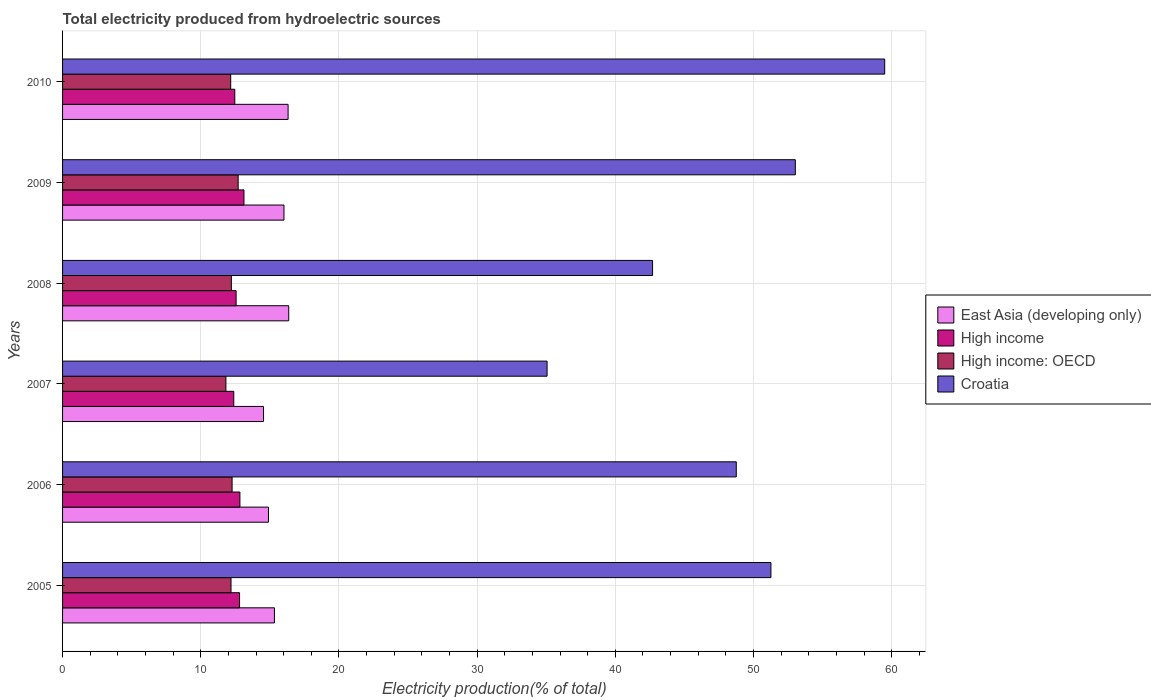How many groups of bars are there?
Offer a terse response. 6. Are the number of bars per tick equal to the number of legend labels?
Provide a succinct answer. Yes. Are the number of bars on each tick of the Y-axis equal?
Keep it short and to the point. Yes. What is the label of the 2nd group of bars from the top?
Make the answer very short. 2009. In how many cases, is the number of bars for a given year not equal to the number of legend labels?
Provide a short and direct response. 0. What is the total electricity produced in Croatia in 2010?
Offer a very short reply. 59.5. Across all years, what is the maximum total electricity produced in High income?
Your answer should be compact. 13.13. Across all years, what is the minimum total electricity produced in Croatia?
Give a very brief answer. 35.06. In which year was the total electricity produced in High income: OECD maximum?
Offer a very short reply. 2009. What is the total total electricity produced in High income in the graph?
Your answer should be very brief. 76.19. What is the difference between the total electricity produced in East Asia (developing only) in 2005 and that in 2010?
Your answer should be compact. -0.99. What is the difference between the total electricity produced in High income in 2006 and the total electricity produced in Croatia in 2010?
Give a very brief answer. -46.66. What is the average total electricity produced in High income: OECD per year?
Give a very brief answer. 12.23. In the year 2006, what is the difference between the total electricity produced in Croatia and total electricity produced in East Asia (developing only)?
Provide a short and direct response. 33.85. What is the ratio of the total electricity produced in East Asia (developing only) in 2005 to that in 2010?
Your answer should be compact. 0.94. Is the total electricity produced in High income in 2007 less than that in 2010?
Your answer should be compact. Yes. Is the difference between the total electricity produced in Croatia in 2009 and 2010 greater than the difference between the total electricity produced in East Asia (developing only) in 2009 and 2010?
Your response must be concise. No. What is the difference between the highest and the second highest total electricity produced in East Asia (developing only)?
Offer a terse response. 0.05. What is the difference between the highest and the lowest total electricity produced in High income: OECD?
Offer a terse response. 0.89. In how many years, is the total electricity produced in High income: OECD greater than the average total electricity produced in High income: OECD taken over all years?
Your answer should be compact. 2. Is the sum of the total electricity produced in Croatia in 2008 and 2010 greater than the maximum total electricity produced in East Asia (developing only) across all years?
Ensure brevity in your answer.  Yes. Is it the case that in every year, the sum of the total electricity produced in Croatia and total electricity produced in High income: OECD is greater than the sum of total electricity produced in East Asia (developing only) and total electricity produced in High income?
Keep it short and to the point. Yes. What does the 4th bar from the top in 2007 represents?
Provide a succinct answer. East Asia (developing only). What does the 3rd bar from the bottom in 2008 represents?
Offer a terse response. High income: OECD. Is it the case that in every year, the sum of the total electricity produced in High income and total electricity produced in East Asia (developing only) is greater than the total electricity produced in High income: OECD?
Your answer should be very brief. Yes. What is the difference between two consecutive major ticks on the X-axis?
Provide a succinct answer. 10. Are the values on the major ticks of X-axis written in scientific E-notation?
Your response must be concise. No. Does the graph contain any zero values?
Your answer should be compact. No. Where does the legend appear in the graph?
Your answer should be very brief. Center right. How many legend labels are there?
Your response must be concise. 4. How are the legend labels stacked?
Give a very brief answer. Vertical. What is the title of the graph?
Provide a succinct answer. Total electricity produced from hydroelectric sources. What is the label or title of the X-axis?
Make the answer very short. Electricity production(% of total). What is the Electricity production(% of total) of East Asia (developing only) in 2005?
Give a very brief answer. 15.33. What is the Electricity production(% of total) of High income in 2005?
Offer a very short reply. 12.81. What is the Electricity production(% of total) of High income: OECD in 2005?
Provide a short and direct response. 12.19. What is the Electricity production(% of total) of Croatia in 2005?
Ensure brevity in your answer.  51.26. What is the Electricity production(% of total) in East Asia (developing only) in 2006?
Provide a succinct answer. 14.9. What is the Electricity production(% of total) of High income in 2006?
Your answer should be compact. 12.83. What is the Electricity production(% of total) in High income: OECD in 2006?
Your answer should be compact. 12.27. What is the Electricity production(% of total) in Croatia in 2006?
Provide a succinct answer. 48.76. What is the Electricity production(% of total) of East Asia (developing only) in 2007?
Offer a very short reply. 14.54. What is the Electricity production(% of total) of High income in 2007?
Offer a very short reply. 12.39. What is the Electricity production(% of total) in High income: OECD in 2007?
Your answer should be compact. 11.82. What is the Electricity production(% of total) of Croatia in 2007?
Offer a very short reply. 35.06. What is the Electricity production(% of total) in East Asia (developing only) in 2008?
Your response must be concise. 16.37. What is the Electricity production(% of total) in High income in 2008?
Ensure brevity in your answer.  12.56. What is the Electricity production(% of total) of High income: OECD in 2008?
Your answer should be compact. 12.21. What is the Electricity production(% of total) of Croatia in 2008?
Your answer should be compact. 42.7. What is the Electricity production(% of total) of East Asia (developing only) in 2009?
Ensure brevity in your answer.  16.02. What is the Electricity production(% of total) in High income in 2009?
Ensure brevity in your answer.  13.13. What is the Electricity production(% of total) in High income: OECD in 2009?
Offer a very short reply. 12.71. What is the Electricity production(% of total) of Croatia in 2009?
Ensure brevity in your answer.  53.03. What is the Electricity production(% of total) in East Asia (developing only) in 2010?
Make the answer very short. 16.32. What is the Electricity production(% of total) in High income in 2010?
Make the answer very short. 12.46. What is the Electricity production(% of total) in High income: OECD in 2010?
Ensure brevity in your answer.  12.17. What is the Electricity production(% of total) in Croatia in 2010?
Provide a succinct answer. 59.5. Across all years, what is the maximum Electricity production(% of total) in East Asia (developing only)?
Your answer should be compact. 16.37. Across all years, what is the maximum Electricity production(% of total) in High income?
Give a very brief answer. 13.13. Across all years, what is the maximum Electricity production(% of total) of High income: OECD?
Keep it short and to the point. 12.71. Across all years, what is the maximum Electricity production(% of total) of Croatia?
Provide a succinct answer. 59.5. Across all years, what is the minimum Electricity production(% of total) in East Asia (developing only)?
Offer a very short reply. 14.54. Across all years, what is the minimum Electricity production(% of total) in High income?
Give a very brief answer. 12.39. Across all years, what is the minimum Electricity production(% of total) of High income: OECD?
Ensure brevity in your answer.  11.82. Across all years, what is the minimum Electricity production(% of total) of Croatia?
Offer a terse response. 35.06. What is the total Electricity production(% of total) of East Asia (developing only) in the graph?
Offer a very short reply. 93.49. What is the total Electricity production(% of total) of High income in the graph?
Your answer should be very brief. 76.19. What is the total Electricity production(% of total) in High income: OECD in the graph?
Your answer should be compact. 73.37. What is the total Electricity production(% of total) in Croatia in the graph?
Your response must be concise. 290.31. What is the difference between the Electricity production(% of total) of East Asia (developing only) in 2005 and that in 2006?
Provide a short and direct response. 0.43. What is the difference between the Electricity production(% of total) of High income in 2005 and that in 2006?
Offer a very short reply. -0.02. What is the difference between the Electricity production(% of total) in High income: OECD in 2005 and that in 2006?
Your response must be concise. -0.08. What is the difference between the Electricity production(% of total) in Croatia in 2005 and that in 2006?
Give a very brief answer. 2.51. What is the difference between the Electricity production(% of total) of East Asia (developing only) in 2005 and that in 2007?
Your answer should be compact. 0.79. What is the difference between the Electricity production(% of total) of High income in 2005 and that in 2007?
Make the answer very short. 0.42. What is the difference between the Electricity production(% of total) of High income: OECD in 2005 and that in 2007?
Offer a very short reply. 0.37. What is the difference between the Electricity production(% of total) in Croatia in 2005 and that in 2007?
Offer a very short reply. 16.2. What is the difference between the Electricity production(% of total) in East Asia (developing only) in 2005 and that in 2008?
Offer a terse response. -1.03. What is the difference between the Electricity production(% of total) of High income in 2005 and that in 2008?
Your response must be concise. 0.25. What is the difference between the Electricity production(% of total) in High income: OECD in 2005 and that in 2008?
Keep it short and to the point. -0.02. What is the difference between the Electricity production(% of total) in Croatia in 2005 and that in 2008?
Offer a terse response. 8.56. What is the difference between the Electricity production(% of total) in East Asia (developing only) in 2005 and that in 2009?
Keep it short and to the point. -0.69. What is the difference between the Electricity production(% of total) of High income in 2005 and that in 2009?
Your response must be concise. -0.32. What is the difference between the Electricity production(% of total) of High income: OECD in 2005 and that in 2009?
Offer a terse response. -0.52. What is the difference between the Electricity production(% of total) of Croatia in 2005 and that in 2009?
Provide a succinct answer. -1.77. What is the difference between the Electricity production(% of total) in East Asia (developing only) in 2005 and that in 2010?
Your answer should be very brief. -0.99. What is the difference between the Electricity production(% of total) of High income in 2005 and that in 2010?
Your response must be concise. 0.35. What is the difference between the Electricity production(% of total) of High income: OECD in 2005 and that in 2010?
Give a very brief answer. 0.02. What is the difference between the Electricity production(% of total) in Croatia in 2005 and that in 2010?
Your answer should be compact. -8.23. What is the difference between the Electricity production(% of total) in East Asia (developing only) in 2006 and that in 2007?
Provide a succinct answer. 0.36. What is the difference between the Electricity production(% of total) in High income in 2006 and that in 2007?
Give a very brief answer. 0.44. What is the difference between the Electricity production(% of total) in High income: OECD in 2006 and that in 2007?
Offer a terse response. 0.45. What is the difference between the Electricity production(% of total) of Croatia in 2006 and that in 2007?
Give a very brief answer. 13.69. What is the difference between the Electricity production(% of total) of East Asia (developing only) in 2006 and that in 2008?
Offer a very short reply. -1.47. What is the difference between the Electricity production(% of total) in High income in 2006 and that in 2008?
Provide a short and direct response. 0.27. What is the difference between the Electricity production(% of total) of High income: OECD in 2006 and that in 2008?
Offer a very short reply. 0.05. What is the difference between the Electricity production(% of total) in Croatia in 2006 and that in 2008?
Provide a succinct answer. 6.06. What is the difference between the Electricity production(% of total) of East Asia (developing only) in 2006 and that in 2009?
Give a very brief answer. -1.12. What is the difference between the Electricity production(% of total) in High income in 2006 and that in 2009?
Make the answer very short. -0.29. What is the difference between the Electricity production(% of total) of High income: OECD in 2006 and that in 2009?
Keep it short and to the point. -0.44. What is the difference between the Electricity production(% of total) of Croatia in 2006 and that in 2009?
Ensure brevity in your answer.  -4.27. What is the difference between the Electricity production(% of total) in East Asia (developing only) in 2006 and that in 2010?
Make the answer very short. -1.42. What is the difference between the Electricity production(% of total) in High income in 2006 and that in 2010?
Offer a terse response. 0.37. What is the difference between the Electricity production(% of total) in High income: OECD in 2006 and that in 2010?
Make the answer very short. 0.1. What is the difference between the Electricity production(% of total) of Croatia in 2006 and that in 2010?
Your answer should be compact. -10.74. What is the difference between the Electricity production(% of total) of East Asia (developing only) in 2007 and that in 2008?
Give a very brief answer. -1.82. What is the difference between the Electricity production(% of total) in High income in 2007 and that in 2008?
Give a very brief answer. -0.17. What is the difference between the Electricity production(% of total) of High income: OECD in 2007 and that in 2008?
Keep it short and to the point. -0.39. What is the difference between the Electricity production(% of total) in Croatia in 2007 and that in 2008?
Your response must be concise. -7.63. What is the difference between the Electricity production(% of total) in East Asia (developing only) in 2007 and that in 2009?
Keep it short and to the point. -1.48. What is the difference between the Electricity production(% of total) in High income in 2007 and that in 2009?
Ensure brevity in your answer.  -0.74. What is the difference between the Electricity production(% of total) of High income: OECD in 2007 and that in 2009?
Offer a terse response. -0.89. What is the difference between the Electricity production(% of total) of Croatia in 2007 and that in 2009?
Offer a very short reply. -17.97. What is the difference between the Electricity production(% of total) in East Asia (developing only) in 2007 and that in 2010?
Make the answer very short. -1.78. What is the difference between the Electricity production(% of total) in High income in 2007 and that in 2010?
Provide a short and direct response. -0.07. What is the difference between the Electricity production(% of total) in High income: OECD in 2007 and that in 2010?
Ensure brevity in your answer.  -0.35. What is the difference between the Electricity production(% of total) of Croatia in 2007 and that in 2010?
Make the answer very short. -24.43. What is the difference between the Electricity production(% of total) of East Asia (developing only) in 2008 and that in 2009?
Offer a very short reply. 0.34. What is the difference between the Electricity production(% of total) of High income in 2008 and that in 2009?
Offer a terse response. -0.57. What is the difference between the Electricity production(% of total) of High income: OECD in 2008 and that in 2009?
Make the answer very short. -0.49. What is the difference between the Electricity production(% of total) in Croatia in 2008 and that in 2009?
Your response must be concise. -10.33. What is the difference between the Electricity production(% of total) of East Asia (developing only) in 2008 and that in 2010?
Your answer should be very brief. 0.05. What is the difference between the Electricity production(% of total) of High income in 2008 and that in 2010?
Your answer should be very brief. 0.1. What is the difference between the Electricity production(% of total) of High income: OECD in 2008 and that in 2010?
Ensure brevity in your answer.  0.05. What is the difference between the Electricity production(% of total) of Croatia in 2008 and that in 2010?
Your response must be concise. -16.8. What is the difference between the Electricity production(% of total) of East Asia (developing only) in 2009 and that in 2010?
Offer a very short reply. -0.3. What is the difference between the Electricity production(% of total) in High income in 2009 and that in 2010?
Ensure brevity in your answer.  0.66. What is the difference between the Electricity production(% of total) in High income: OECD in 2009 and that in 2010?
Provide a short and direct response. 0.54. What is the difference between the Electricity production(% of total) of Croatia in 2009 and that in 2010?
Your answer should be compact. -6.47. What is the difference between the Electricity production(% of total) in East Asia (developing only) in 2005 and the Electricity production(% of total) in High income in 2006?
Give a very brief answer. 2.5. What is the difference between the Electricity production(% of total) of East Asia (developing only) in 2005 and the Electricity production(% of total) of High income: OECD in 2006?
Provide a succinct answer. 3.06. What is the difference between the Electricity production(% of total) of East Asia (developing only) in 2005 and the Electricity production(% of total) of Croatia in 2006?
Your response must be concise. -33.42. What is the difference between the Electricity production(% of total) in High income in 2005 and the Electricity production(% of total) in High income: OECD in 2006?
Offer a very short reply. 0.54. What is the difference between the Electricity production(% of total) of High income in 2005 and the Electricity production(% of total) of Croatia in 2006?
Provide a succinct answer. -35.95. What is the difference between the Electricity production(% of total) of High income: OECD in 2005 and the Electricity production(% of total) of Croatia in 2006?
Make the answer very short. -36.57. What is the difference between the Electricity production(% of total) of East Asia (developing only) in 2005 and the Electricity production(% of total) of High income in 2007?
Offer a terse response. 2.94. What is the difference between the Electricity production(% of total) in East Asia (developing only) in 2005 and the Electricity production(% of total) in High income: OECD in 2007?
Your answer should be compact. 3.51. What is the difference between the Electricity production(% of total) of East Asia (developing only) in 2005 and the Electricity production(% of total) of Croatia in 2007?
Provide a short and direct response. -19.73. What is the difference between the Electricity production(% of total) in High income in 2005 and the Electricity production(% of total) in High income: OECD in 2007?
Your answer should be compact. 0.99. What is the difference between the Electricity production(% of total) of High income in 2005 and the Electricity production(% of total) of Croatia in 2007?
Your answer should be very brief. -22.25. What is the difference between the Electricity production(% of total) in High income: OECD in 2005 and the Electricity production(% of total) in Croatia in 2007?
Ensure brevity in your answer.  -22.87. What is the difference between the Electricity production(% of total) in East Asia (developing only) in 2005 and the Electricity production(% of total) in High income in 2008?
Give a very brief answer. 2.77. What is the difference between the Electricity production(% of total) of East Asia (developing only) in 2005 and the Electricity production(% of total) of High income: OECD in 2008?
Give a very brief answer. 3.12. What is the difference between the Electricity production(% of total) of East Asia (developing only) in 2005 and the Electricity production(% of total) of Croatia in 2008?
Your answer should be compact. -27.37. What is the difference between the Electricity production(% of total) in High income in 2005 and the Electricity production(% of total) in High income: OECD in 2008?
Your response must be concise. 0.59. What is the difference between the Electricity production(% of total) in High income in 2005 and the Electricity production(% of total) in Croatia in 2008?
Your answer should be very brief. -29.89. What is the difference between the Electricity production(% of total) of High income: OECD in 2005 and the Electricity production(% of total) of Croatia in 2008?
Make the answer very short. -30.51. What is the difference between the Electricity production(% of total) of East Asia (developing only) in 2005 and the Electricity production(% of total) of High income in 2009?
Your answer should be compact. 2.2. What is the difference between the Electricity production(% of total) in East Asia (developing only) in 2005 and the Electricity production(% of total) in High income: OECD in 2009?
Make the answer very short. 2.63. What is the difference between the Electricity production(% of total) of East Asia (developing only) in 2005 and the Electricity production(% of total) of Croatia in 2009?
Keep it short and to the point. -37.7. What is the difference between the Electricity production(% of total) in High income in 2005 and the Electricity production(% of total) in High income: OECD in 2009?
Your answer should be compact. 0.1. What is the difference between the Electricity production(% of total) in High income in 2005 and the Electricity production(% of total) in Croatia in 2009?
Offer a very short reply. -40.22. What is the difference between the Electricity production(% of total) of High income: OECD in 2005 and the Electricity production(% of total) of Croatia in 2009?
Give a very brief answer. -40.84. What is the difference between the Electricity production(% of total) of East Asia (developing only) in 2005 and the Electricity production(% of total) of High income in 2010?
Provide a succinct answer. 2.87. What is the difference between the Electricity production(% of total) in East Asia (developing only) in 2005 and the Electricity production(% of total) in High income: OECD in 2010?
Your answer should be very brief. 3.16. What is the difference between the Electricity production(% of total) in East Asia (developing only) in 2005 and the Electricity production(% of total) in Croatia in 2010?
Offer a very short reply. -44.16. What is the difference between the Electricity production(% of total) of High income in 2005 and the Electricity production(% of total) of High income: OECD in 2010?
Provide a succinct answer. 0.64. What is the difference between the Electricity production(% of total) in High income in 2005 and the Electricity production(% of total) in Croatia in 2010?
Your answer should be compact. -46.69. What is the difference between the Electricity production(% of total) of High income: OECD in 2005 and the Electricity production(% of total) of Croatia in 2010?
Offer a terse response. -47.31. What is the difference between the Electricity production(% of total) of East Asia (developing only) in 2006 and the Electricity production(% of total) of High income in 2007?
Keep it short and to the point. 2.51. What is the difference between the Electricity production(% of total) of East Asia (developing only) in 2006 and the Electricity production(% of total) of High income: OECD in 2007?
Keep it short and to the point. 3.08. What is the difference between the Electricity production(% of total) in East Asia (developing only) in 2006 and the Electricity production(% of total) in Croatia in 2007?
Your answer should be very brief. -20.16. What is the difference between the Electricity production(% of total) of High income in 2006 and the Electricity production(% of total) of High income: OECD in 2007?
Offer a very short reply. 1.01. What is the difference between the Electricity production(% of total) of High income in 2006 and the Electricity production(% of total) of Croatia in 2007?
Your answer should be very brief. -22.23. What is the difference between the Electricity production(% of total) of High income: OECD in 2006 and the Electricity production(% of total) of Croatia in 2007?
Offer a very short reply. -22.8. What is the difference between the Electricity production(% of total) in East Asia (developing only) in 2006 and the Electricity production(% of total) in High income in 2008?
Ensure brevity in your answer.  2.34. What is the difference between the Electricity production(% of total) in East Asia (developing only) in 2006 and the Electricity production(% of total) in High income: OECD in 2008?
Offer a very short reply. 2.69. What is the difference between the Electricity production(% of total) of East Asia (developing only) in 2006 and the Electricity production(% of total) of Croatia in 2008?
Provide a short and direct response. -27.8. What is the difference between the Electricity production(% of total) in High income in 2006 and the Electricity production(% of total) in High income: OECD in 2008?
Make the answer very short. 0.62. What is the difference between the Electricity production(% of total) in High income in 2006 and the Electricity production(% of total) in Croatia in 2008?
Offer a very short reply. -29.86. What is the difference between the Electricity production(% of total) in High income: OECD in 2006 and the Electricity production(% of total) in Croatia in 2008?
Offer a terse response. -30.43. What is the difference between the Electricity production(% of total) of East Asia (developing only) in 2006 and the Electricity production(% of total) of High income in 2009?
Provide a short and direct response. 1.77. What is the difference between the Electricity production(% of total) of East Asia (developing only) in 2006 and the Electricity production(% of total) of High income: OECD in 2009?
Your response must be concise. 2.19. What is the difference between the Electricity production(% of total) in East Asia (developing only) in 2006 and the Electricity production(% of total) in Croatia in 2009?
Ensure brevity in your answer.  -38.13. What is the difference between the Electricity production(% of total) of High income in 2006 and the Electricity production(% of total) of High income: OECD in 2009?
Offer a terse response. 0.13. What is the difference between the Electricity production(% of total) of High income in 2006 and the Electricity production(% of total) of Croatia in 2009?
Give a very brief answer. -40.2. What is the difference between the Electricity production(% of total) in High income: OECD in 2006 and the Electricity production(% of total) in Croatia in 2009?
Offer a very short reply. -40.76. What is the difference between the Electricity production(% of total) of East Asia (developing only) in 2006 and the Electricity production(% of total) of High income in 2010?
Your answer should be very brief. 2.44. What is the difference between the Electricity production(% of total) of East Asia (developing only) in 2006 and the Electricity production(% of total) of High income: OECD in 2010?
Make the answer very short. 2.73. What is the difference between the Electricity production(% of total) in East Asia (developing only) in 2006 and the Electricity production(% of total) in Croatia in 2010?
Give a very brief answer. -44.59. What is the difference between the Electricity production(% of total) in High income in 2006 and the Electricity production(% of total) in High income: OECD in 2010?
Your answer should be compact. 0.67. What is the difference between the Electricity production(% of total) in High income in 2006 and the Electricity production(% of total) in Croatia in 2010?
Ensure brevity in your answer.  -46.66. What is the difference between the Electricity production(% of total) in High income: OECD in 2006 and the Electricity production(% of total) in Croatia in 2010?
Give a very brief answer. -47.23. What is the difference between the Electricity production(% of total) in East Asia (developing only) in 2007 and the Electricity production(% of total) in High income in 2008?
Your answer should be very brief. 1.98. What is the difference between the Electricity production(% of total) of East Asia (developing only) in 2007 and the Electricity production(% of total) of High income: OECD in 2008?
Offer a terse response. 2.33. What is the difference between the Electricity production(% of total) in East Asia (developing only) in 2007 and the Electricity production(% of total) in Croatia in 2008?
Give a very brief answer. -28.15. What is the difference between the Electricity production(% of total) of High income in 2007 and the Electricity production(% of total) of High income: OECD in 2008?
Your answer should be compact. 0.17. What is the difference between the Electricity production(% of total) in High income in 2007 and the Electricity production(% of total) in Croatia in 2008?
Offer a very short reply. -30.31. What is the difference between the Electricity production(% of total) in High income: OECD in 2007 and the Electricity production(% of total) in Croatia in 2008?
Provide a short and direct response. -30.88. What is the difference between the Electricity production(% of total) of East Asia (developing only) in 2007 and the Electricity production(% of total) of High income in 2009?
Provide a short and direct response. 1.42. What is the difference between the Electricity production(% of total) in East Asia (developing only) in 2007 and the Electricity production(% of total) in High income: OECD in 2009?
Provide a short and direct response. 1.84. What is the difference between the Electricity production(% of total) of East Asia (developing only) in 2007 and the Electricity production(% of total) of Croatia in 2009?
Your response must be concise. -38.49. What is the difference between the Electricity production(% of total) of High income in 2007 and the Electricity production(% of total) of High income: OECD in 2009?
Your answer should be compact. -0.32. What is the difference between the Electricity production(% of total) in High income in 2007 and the Electricity production(% of total) in Croatia in 2009?
Make the answer very short. -40.64. What is the difference between the Electricity production(% of total) of High income: OECD in 2007 and the Electricity production(% of total) of Croatia in 2009?
Give a very brief answer. -41.21. What is the difference between the Electricity production(% of total) of East Asia (developing only) in 2007 and the Electricity production(% of total) of High income in 2010?
Your response must be concise. 2.08. What is the difference between the Electricity production(% of total) of East Asia (developing only) in 2007 and the Electricity production(% of total) of High income: OECD in 2010?
Provide a short and direct response. 2.38. What is the difference between the Electricity production(% of total) of East Asia (developing only) in 2007 and the Electricity production(% of total) of Croatia in 2010?
Offer a terse response. -44.95. What is the difference between the Electricity production(% of total) in High income in 2007 and the Electricity production(% of total) in High income: OECD in 2010?
Offer a very short reply. 0.22. What is the difference between the Electricity production(% of total) of High income in 2007 and the Electricity production(% of total) of Croatia in 2010?
Your answer should be compact. -47.11. What is the difference between the Electricity production(% of total) of High income: OECD in 2007 and the Electricity production(% of total) of Croatia in 2010?
Offer a very short reply. -47.68. What is the difference between the Electricity production(% of total) of East Asia (developing only) in 2008 and the Electricity production(% of total) of High income in 2009?
Provide a succinct answer. 3.24. What is the difference between the Electricity production(% of total) in East Asia (developing only) in 2008 and the Electricity production(% of total) in High income: OECD in 2009?
Offer a terse response. 3.66. What is the difference between the Electricity production(% of total) of East Asia (developing only) in 2008 and the Electricity production(% of total) of Croatia in 2009?
Make the answer very short. -36.66. What is the difference between the Electricity production(% of total) of High income in 2008 and the Electricity production(% of total) of High income: OECD in 2009?
Give a very brief answer. -0.15. What is the difference between the Electricity production(% of total) in High income in 2008 and the Electricity production(% of total) in Croatia in 2009?
Your answer should be very brief. -40.47. What is the difference between the Electricity production(% of total) in High income: OECD in 2008 and the Electricity production(% of total) in Croatia in 2009?
Your response must be concise. -40.81. What is the difference between the Electricity production(% of total) in East Asia (developing only) in 2008 and the Electricity production(% of total) in High income in 2010?
Your answer should be very brief. 3.9. What is the difference between the Electricity production(% of total) in East Asia (developing only) in 2008 and the Electricity production(% of total) in High income: OECD in 2010?
Provide a succinct answer. 4.2. What is the difference between the Electricity production(% of total) in East Asia (developing only) in 2008 and the Electricity production(% of total) in Croatia in 2010?
Provide a succinct answer. -43.13. What is the difference between the Electricity production(% of total) in High income in 2008 and the Electricity production(% of total) in High income: OECD in 2010?
Offer a very short reply. 0.39. What is the difference between the Electricity production(% of total) of High income in 2008 and the Electricity production(% of total) of Croatia in 2010?
Provide a succinct answer. -46.94. What is the difference between the Electricity production(% of total) of High income: OECD in 2008 and the Electricity production(% of total) of Croatia in 2010?
Ensure brevity in your answer.  -47.28. What is the difference between the Electricity production(% of total) of East Asia (developing only) in 2009 and the Electricity production(% of total) of High income in 2010?
Provide a succinct answer. 3.56. What is the difference between the Electricity production(% of total) in East Asia (developing only) in 2009 and the Electricity production(% of total) in High income: OECD in 2010?
Offer a very short reply. 3.85. What is the difference between the Electricity production(% of total) in East Asia (developing only) in 2009 and the Electricity production(% of total) in Croatia in 2010?
Keep it short and to the point. -43.47. What is the difference between the Electricity production(% of total) in High income in 2009 and the Electricity production(% of total) in High income: OECD in 2010?
Offer a terse response. 0.96. What is the difference between the Electricity production(% of total) of High income in 2009 and the Electricity production(% of total) of Croatia in 2010?
Offer a terse response. -46.37. What is the difference between the Electricity production(% of total) in High income: OECD in 2009 and the Electricity production(% of total) in Croatia in 2010?
Your response must be concise. -46.79. What is the average Electricity production(% of total) of East Asia (developing only) per year?
Make the answer very short. 15.58. What is the average Electricity production(% of total) of High income per year?
Provide a short and direct response. 12.7. What is the average Electricity production(% of total) of High income: OECD per year?
Ensure brevity in your answer.  12.23. What is the average Electricity production(% of total) of Croatia per year?
Provide a short and direct response. 48.38. In the year 2005, what is the difference between the Electricity production(% of total) in East Asia (developing only) and Electricity production(% of total) in High income?
Make the answer very short. 2.52. In the year 2005, what is the difference between the Electricity production(% of total) of East Asia (developing only) and Electricity production(% of total) of High income: OECD?
Your response must be concise. 3.14. In the year 2005, what is the difference between the Electricity production(% of total) of East Asia (developing only) and Electricity production(% of total) of Croatia?
Your response must be concise. -35.93. In the year 2005, what is the difference between the Electricity production(% of total) in High income and Electricity production(% of total) in High income: OECD?
Make the answer very short. 0.62. In the year 2005, what is the difference between the Electricity production(% of total) of High income and Electricity production(% of total) of Croatia?
Your answer should be very brief. -38.45. In the year 2005, what is the difference between the Electricity production(% of total) of High income: OECD and Electricity production(% of total) of Croatia?
Keep it short and to the point. -39.07. In the year 2006, what is the difference between the Electricity production(% of total) of East Asia (developing only) and Electricity production(% of total) of High income?
Give a very brief answer. 2.07. In the year 2006, what is the difference between the Electricity production(% of total) of East Asia (developing only) and Electricity production(% of total) of High income: OECD?
Provide a short and direct response. 2.63. In the year 2006, what is the difference between the Electricity production(% of total) of East Asia (developing only) and Electricity production(% of total) of Croatia?
Make the answer very short. -33.85. In the year 2006, what is the difference between the Electricity production(% of total) of High income and Electricity production(% of total) of High income: OECD?
Ensure brevity in your answer.  0.57. In the year 2006, what is the difference between the Electricity production(% of total) in High income and Electricity production(% of total) in Croatia?
Your answer should be very brief. -35.92. In the year 2006, what is the difference between the Electricity production(% of total) of High income: OECD and Electricity production(% of total) of Croatia?
Your answer should be very brief. -36.49. In the year 2007, what is the difference between the Electricity production(% of total) of East Asia (developing only) and Electricity production(% of total) of High income?
Your answer should be very brief. 2.15. In the year 2007, what is the difference between the Electricity production(% of total) of East Asia (developing only) and Electricity production(% of total) of High income: OECD?
Provide a succinct answer. 2.72. In the year 2007, what is the difference between the Electricity production(% of total) of East Asia (developing only) and Electricity production(% of total) of Croatia?
Your response must be concise. -20.52. In the year 2007, what is the difference between the Electricity production(% of total) in High income and Electricity production(% of total) in High income: OECD?
Provide a short and direct response. 0.57. In the year 2007, what is the difference between the Electricity production(% of total) of High income and Electricity production(% of total) of Croatia?
Provide a short and direct response. -22.67. In the year 2007, what is the difference between the Electricity production(% of total) of High income: OECD and Electricity production(% of total) of Croatia?
Give a very brief answer. -23.24. In the year 2008, what is the difference between the Electricity production(% of total) in East Asia (developing only) and Electricity production(% of total) in High income?
Offer a very short reply. 3.81. In the year 2008, what is the difference between the Electricity production(% of total) of East Asia (developing only) and Electricity production(% of total) of High income: OECD?
Keep it short and to the point. 4.15. In the year 2008, what is the difference between the Electricity production(% of total) in East Asia (developing only) and Electricity production(% of total) in Croatia?
Your answer should be compact. -26.33. In the year 2008, what is the difference between the Electricity production(% of total) in High income and Electricity production(% of total) in High income: OECD?
Provide a succinct answer. 0.34. In the year 2008, what is the difference between the Electricity production(% of total) of High income and Electricity production(% of total) of Croatia?
Your answer should be very brief. -30.14. In the year 2008, what is the difference between the Electricity production(% of total) in High income: OECD and Electricity production(% of total) in Croatia?
Make the answer very short. -30.48. In the year 2009, what is the difference between the Electricity production(% of total) of East Asia (developing only) and Electricity production(% of total) of High income?
Give a very brief answer. 2.89. In the year 2009, what is the difference between the Electricity production(% of total) of East Asia (developing only) and Electricity production(% of total) of High income: OECD?
Your answer should be compact. 3.32. In the year 2009, what is the difference between the Electricity production(% of total) in East Asia (developing only) and Electricity production(% of total) in Croatia?
Your answer should be very brief. -37.01. In the year 2009, what is the difference between the Electricity production(% of total) of High income and Electricity production(% of total) of High income: OECD?
Make the answer very short. 0.42. In the year 2009, what is the difference between the Electricity production(% of total) of High income and Electricity production(% of total) of Croatia?
Ensure brevity in your answer.  -39.9. In the year 2009, what is the difference between the Electricity production(% of total) in High income: OECD and Electricity production(% of total) in Croatia?
Ensure brevity in your answer.  -40.32. In the year 2010, what is the difference between the Electricity production(% of total) of East Asia (developing only) and Electricity production(% of total) of High income?
Ensure brevity in your answer.  3.86. In the year 2010, what is the difference between the Electricity production(% of total) in East Asia (developing only) and Electricity production(% of total) in High income: OECD?
Offer a very short reply. 4.15. In the year 2010, what is the difference between the Electricity production(% of total) in East Asia (developing only) and Electricity production(% of total) in Croatia?
Provide a short and direct response. -43.18. In the year 2010, what is the difference between the Electricity production(% of total) of High income and Electricity production(% of total) of High income: OECD?
Give a very brief answer. 0.3. In the year 2010, what is the difference between the Electricity production(% of total) in High income and Electricity production(% of total) in Croatia?
Provide a short and direct response. -47.03. In the year 2010, what is the difference between the Electricity production(% of total) in High income: OECD and Electricity production(% of total) in Croatia?
Provide a succinct answer. -47.33. What is the ratio of the Electricity production(% of total) in East Asia (developing only) in 2005 to that in 2006?
Make the answer very short. 1.03. What is the ratio of the Electricity production(% of total) of Croatia in 2005 to that in 2006?
Provide a succinct answer. 1.05. What is the ratio of the Electricity production(% of total) in East Asia (developing only) in 2005 to that in 2007?
Offer a very short reply. 1.05. What is the ratio of the Electricity production(% of total) in High income in 2005 to that in 2007?
Provide a succinct answer. 1.03. What is the ratio of the Electricity production(% of total) of High income: OECD in 2005 to that in 2007?
Keep it short and to the point. 1.03. What is the ratio of the Electricity production(% of total) of Croatia in 2005 to that in 2007?
Provide a short and direct response. 1.46. What is the ratio of the Electricity production(% of total) of East Asia (developing only) in 2005 to that in 2008?
Your answer should be compact. 0.94. What is the ratio of the Electricity production(% of total) in High income in 2005 to that in 2008?
Your answer should be compact. 1.02. What is the ratio of the Electricity production(% of total) in High income: OECD in 2005 to that in 2008?
Your response must be concise. 1. What is the ratio of the Electricity production(% of total) in Croatia in 2005 to that in 2008?
Your answer should be very brief. 1.2. What is the ratio of the Electricity production(% of total) of East Asia (developing only) in 2005 to that in 2009?
Your response must be concise. 0.96. What is the ratio of the Electricity production(% of total) in High income in 2005 to that in 2009?
Your answer should be compact. 0.98. What is the ratio of the Electricity production(% of total) of High income: OECD in 2005 to that in 2009?
Your answer should be compact. 0.96. What is the ratio of the Electricity production(% of total) of Croatia in 2005 to that in 2009?
Offer a terse response. 0.97. What is the ratio of the Electricity production(% of total) of East Asia (developing only) in 2005 to that in 2010?
Give a very brief answer. 0.94. What is the ratio of the Electricity production(% of total) in High income in 2005 to that in 2010?
Provide a short and direct response. 1.03. What is the ratio of the Electricity production(% of total) in High income: OECD in 2005 to that in 2010?
Keep it short and to the point. 1. What is the ratio of the Electricity production(% of total) of Croatia in 2005 to that in 2010?
Provide a short and direct response. 0.86. What is the ratio of the Electricity production(% of total) of East Asia (developing only) in 2006 to that in 2007?
Your answer should be very brief. 1.02. What is the ratio of the Electricity production(% of total) in High income in 2006 to that in 2007?
Offer a terse response. 1.04. What is the ratio of the Electricity production(% of total) of High income: OECD in 2006 to that in 2007?
Provide a short and direct response. 1.04. What is the ratio of the Electricity production(% of total) in Croatia in 2006 to that in 2007?
Your response must be concise. 1.39. What is the ratio of the Electricity production(% of total) of East Asia (developing only) in 2006 to that in 2008?
Provide a short and direct response. 0.91. What is the ratio of the Electricity production(% of total) in High income in 2006 to that in 2008?
Make the answer very short. 1.02. What is the ratio of the Electricity production(% of total) in Croatia in 2006 to that in 2008?
Provide a succinct answer. 1.14. What is the ratio of the Electricity production(% of total) of East Asia (developing only) in 2006 to that in 2009?
Make the answer very short. 0.93. What is the ratio of the Electricity production(% of total) in High income in 2006 to that in 2009?
Keep it short and to the point. 0.98. What is the ratio of the Electricity production(% of total) in High income: OECD in 2006 to that in 2009?
Provide a succinct answer. 0.97. What is the ratio of the Electricity production(% of total) of Croatia in 2006 to that in 2009?
Your answer should be compact. 0.92. What is the ratio of the Electricity production(% of total) in High income in 2006 to that in 2010?
Make the answer very short. 1.03. What is the ratio of the Electricity production(% of total) of High income: OECD in 2006 to that in 2010?
Make the answer very short. 1.01. What is the ratio of the Electricity production(% of total) of Croatia in 2006 to that in 2010?
Ensure brevity in your answer.  0.82. What is the ratio of the Electricity production(% of total) in East Asia (developing only) in 2007 to that in 2008?
Offer a terse response. 0.89. What is the ratio of the Electricity production(% of total) of High income in 2007 to that in 2008?
Offer a terse response. 0.99. What is the ratio of the Electricity production(% of total) of Croatia in 2007 to that in 2008?
Offer a terse response. 0.82. What is the ratio of the Electricity production(% of total) in East Asia (developing only) in 2007 to that in 2009?
Offer a very short reply. 0.91. What is the ratio of the Electricity production(% of total) of High income in 2007 to that in 2009?
Give a very brief answer. 0.94. What is the ratio of the Electricity production(% of total) of High income: OECD in 2007 to that in 2009?
Give a very brief answer. 0.93. What is the ratio of the Electricity production(% of total) in Croatia in 2007 to that in 2009?
Your answer should be compact. 0.66. What is the ratio of the Electricity production(% of total) of East Asia (developing only) in 2007 to that in 2010?
Provide a succinct answer. 0.89. What is the ratio of the Electricity production(% of total) of High income in 2007 to that in 2010?
Provide a succinct answer. 0.99. What is the ratio of the Electricity production(% of total) in High income: OECD in 2007 to that in 2010?
Your answer should be compact. 0.97. What is the ratio of the Electricity production(% of total) in Croatia in 2007 to that in 2010?
Your answer should be very brief. 0.59. What is the ratio of the Electricity production(% of total) of East Asia (developing only) in 2008 to that in 2009?
Your answer should be compact. 1.02. What is the ratio of the Electricity production(% of total) in High income in 2008 to that in 2009?
Your response must be concise. 0.96. What is the ratio of the Electricity production(% of total) of High income: OECD in 2008 to that in 2009?
Ensure brevity in your answer.  0.96. What is the ratio of the Electricity production(% of total) in Croatia in 2008 to that in 2009?
Provide a short and direct response. 0.81. What is the ratio of the Electricity production(% of total) in High income in 2008 to that in 2010?
Offer a very short reply. 1.01. What is the ratio of the Electricity production(% of total) of Croatia in 2008 to that in 2010?
Your answer should be compact. 0.72. What is the ratio of the Electricity production(% of total) in East Asia (developing only) in 2009 to that in 2010?
Give a very brief answer. 0.98. What is the ratio of the Electricity production(% of total) in High income in 2009 to that in 2010?
Give a very brief answer. 1.05. What is the ratio of the Electricity production(% of total) in High income: OECD in 2009 to that in 2010?
Offer a terse response. 1.04. What is the ratio of the Electricity production(% of total) in Croatia in 2009 to that in 2010?
Your answer should be compact. 0.89. What is the difference between the highest and the second highest Electricity production(% of total) in East Asia (developing only)?
Keep it short and to the point. 0.05. What is the difference between the highest and the second highest Electricity production(% of total) in High income?
Offer a very short reply. 0.29. What is the difference between the highest and the second highest Electricity production(% of total) in High income: OECD?
Offer a terse response. 0.44. What is the difference between the highest and the second highest Electricity production(% of total) in Croatia?
Give a very brief answer. 6.47. What is the difference between the highest and the lowest Electricity production(% of total) of East Asia (developing only)?
Your answer should be very brief. 1.82. What is the difference between the highest and the lowest Electricity production(% of total) of High income?
Ensure brevity in your answer.  0.74. What is the difference between the highest and the lowest Electricity production(% of total) in High income: OECD?
Make the answer very short. 0.89. What is the difference between the highest and the lowest Electricity production(% of total) in Croatia?
Offer a terse response. 24.43. 